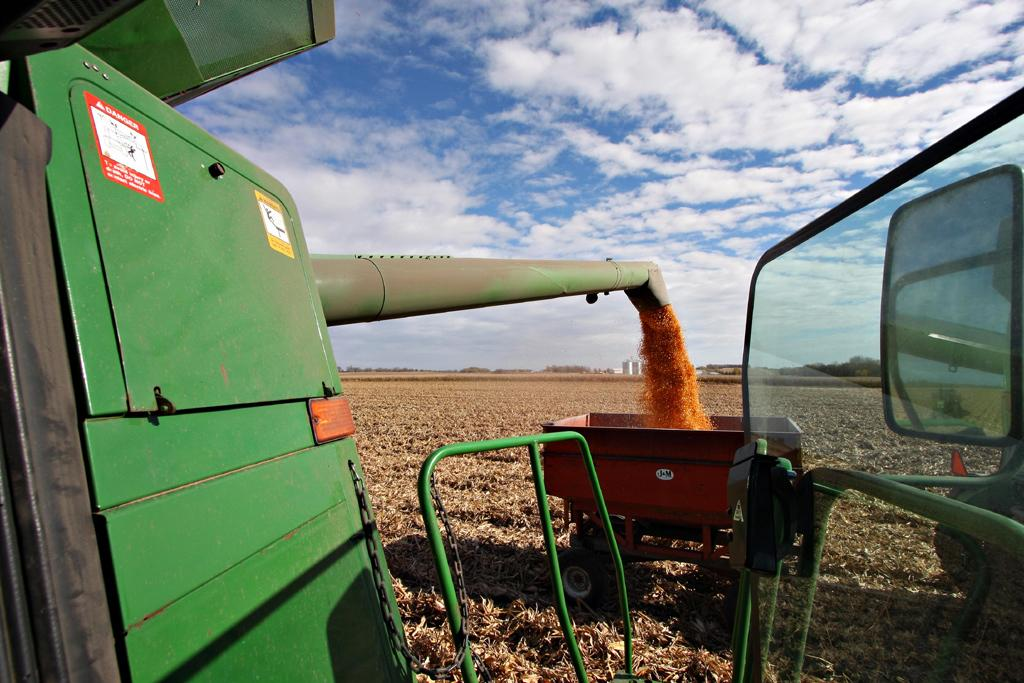What is the main object in the image? There is a machine in the image. What else can be seen in the image besides the machine? There is a trolley in the image. What is the ground covered with in the image? There is dry grass on the ground from left to right. What can be seen in the distance in the image? There are trees in the background of the image. What type of popcorn is being shown in the image? There is no popcorn present in the image. What is being printed on the machine in the image? The image does not show any printing activity on the machine. 